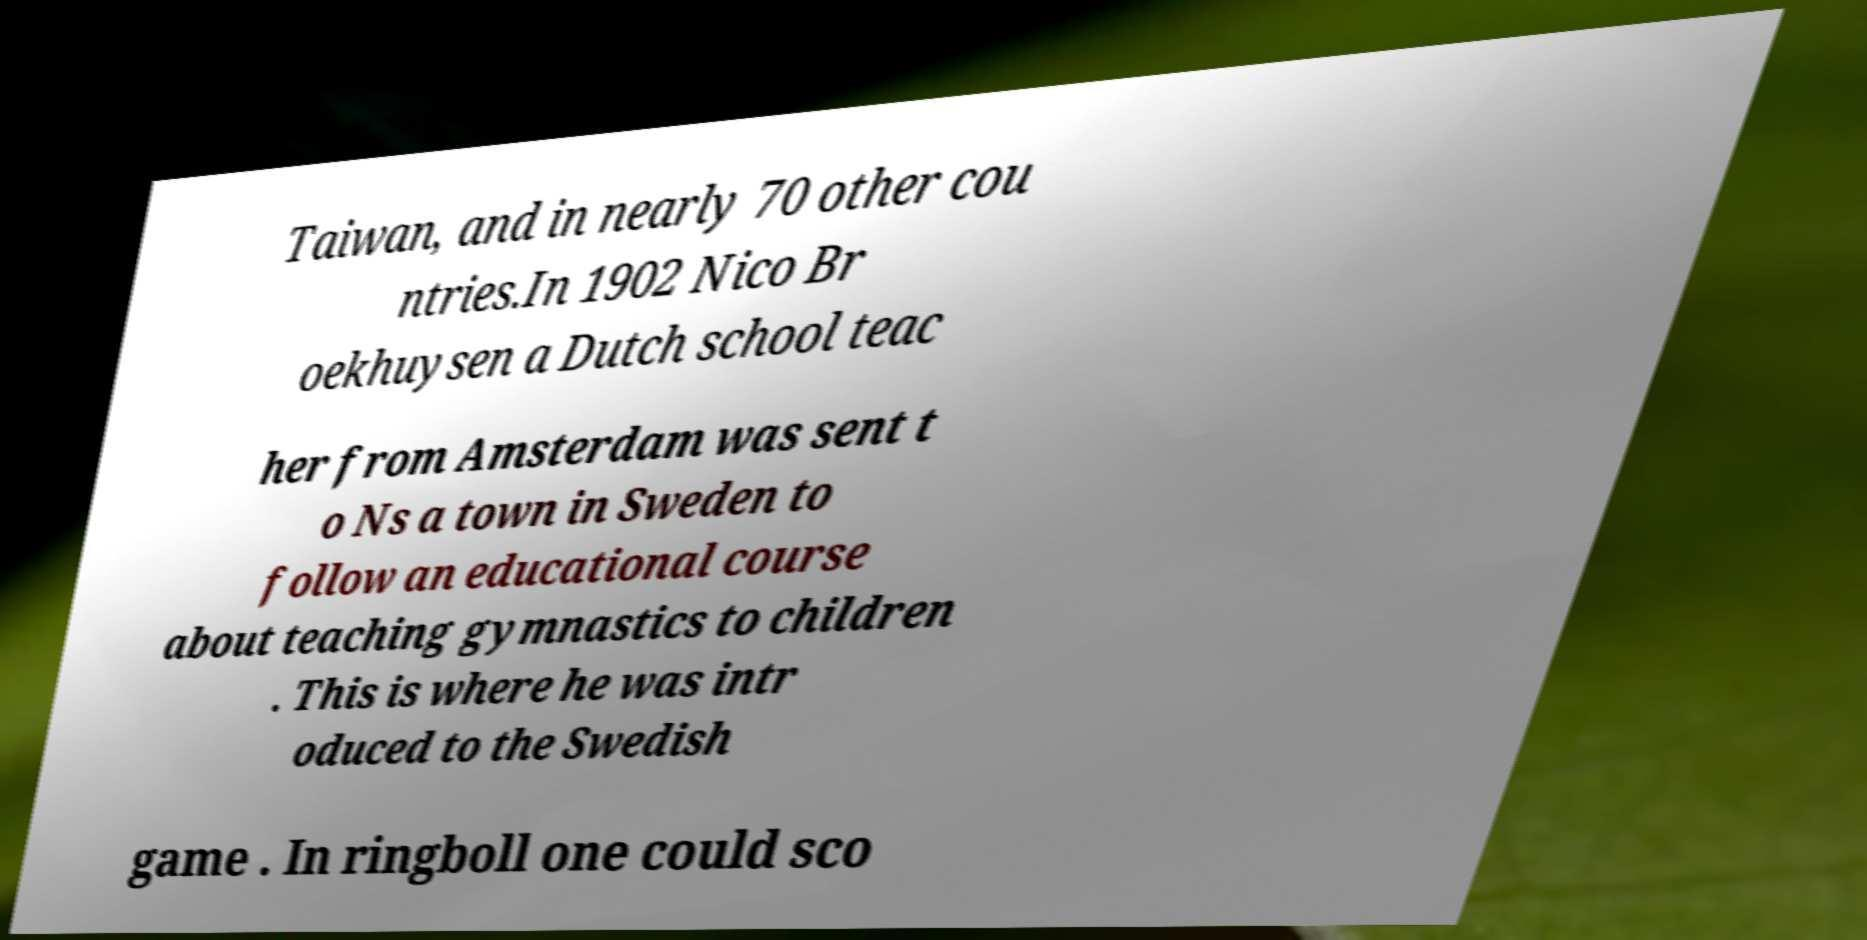For documentation purposes, I need the text within this image transcribed. Could you provide that? Taiwan, and in nearly 70 other cou ntries.In 1902 Nico Br oekhuysen a Dutch school teac her from Amsterdam was sent t o Ns a town in Sweden to follow an educational course about teaching gymnastics to children . This is where he was intr oduced to the Swedish game . In ringboll one could sco 